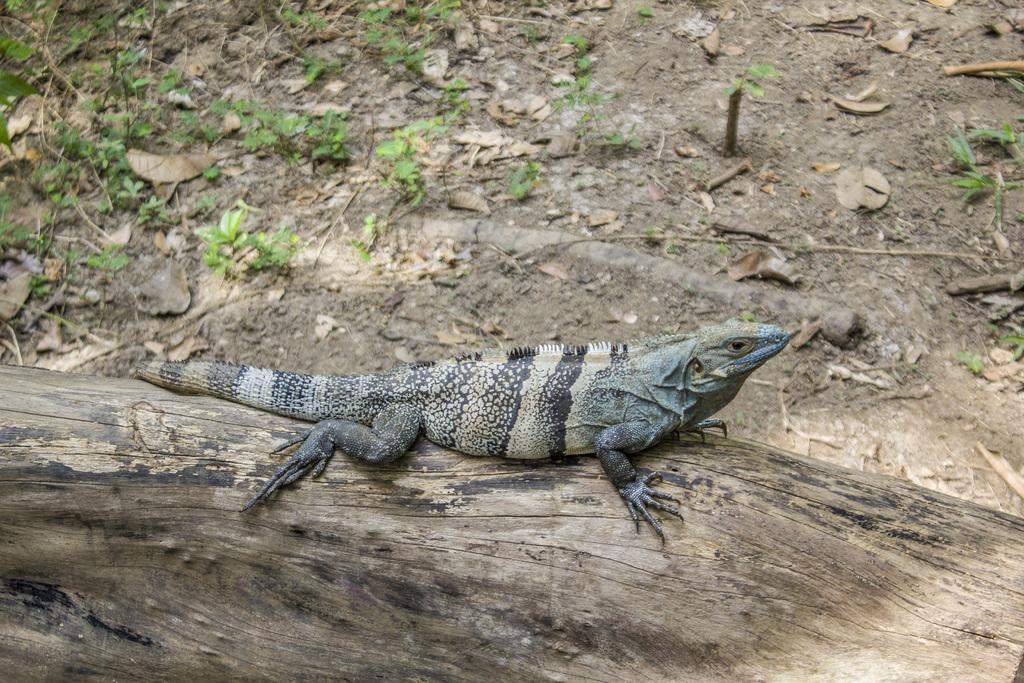What type of animal is on the wood in the image? There is a reptile on the wood in the image. What can be seen on the ground in the image? There are dry leaves and plants on the ground in the image. What is the credit score of the reptile in the image? There is no information about the reptile's credit score in the image, as credit scores are not applicable to animals. 